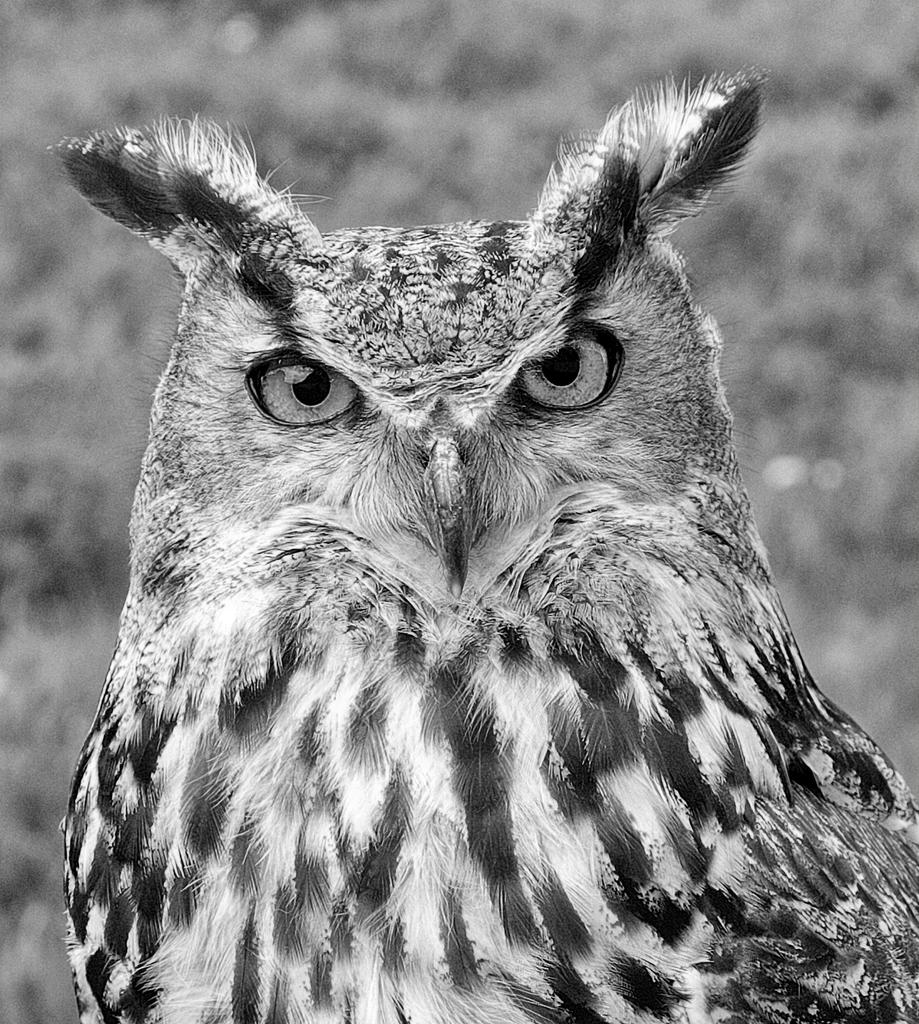What type of animal is in the picture? There is an eagle in the picture. What color is the ink used to draw the eagle in the picture? There is no information about ink or drawing in the provided fact, as it only states that there is an eagle in the picture. 